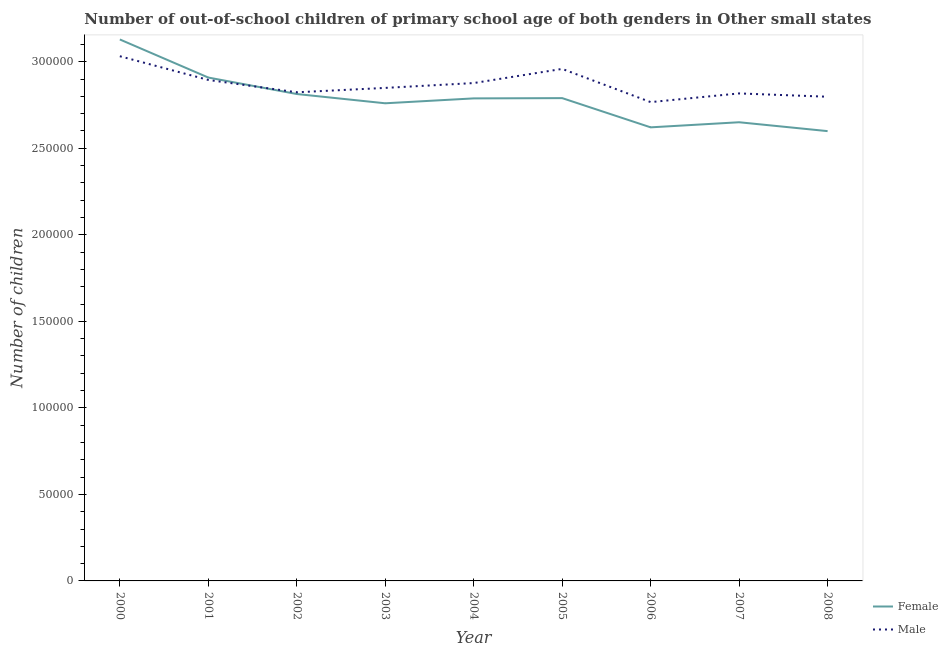Is the number of lines equal to the number of legend labels?
Give a very brief answer. Yes. What is the number of male out-of-school students in 2006?
Your answer should be compact. 2.77e+05. Across all years, what is the maximum number of male out-of-school students?
Keep it short and to the point. 3.03e+05. Across all years, what is the minimum number of male out-of-school students?
Ensure brevity in your answer.  2.77e+05. In which year was the number of female out-of-school students minimum?
Ensure brevity in your answer.  2008. What is the total number of male out-of-school students in the graph?
Offer a terse response. 2.58e+06. What is the difference between the number of male out-of-school students in 2003 and that in 2005?
Ensure brevity in your answer.  -1.10e+04. What is the difference between the number of female out-of-school students in 2004 and the number of male out-of-school students in 2001?
Give a very brief answer. -1.07e+04. What is the average number of female out-of-school students per year?
Offer a terse response. 2.78e+05. In the year 2008, what is the difference between the number of male out-of-school students and number of female out-of-school students?
Your response must be concise. 1.99e+04. What is the ratio of the number of female out-of-school students in 2000 to that in 2006?
Offer a very short reply. 1.19. Is the number of male out-of-school students in 2001 less than that in 2002?
Provide a succinct answer. No. Is the difference between the number of female out-of-school students in 2000 and 2008 greater than the difference between the number of male out-of-school students in 2000 and 2008?
Provide a succinct answer. Yes. What is the difference between the highest and the second highest number of female out-of-school students?
Your answer should be very brief. 2.20e+04. What is the difference between the highest and the lowest number of male out-of-school students?
Ensure brevity in your answer.  2.65e+04. In how many years, is the number of female out-of-school students greater than the average number of female out-of-school students taken over all years?
Keep it short and to the point. 5. Does the number of male out-of-school students monotonically increase over the years?
Provide a short and direct response. No. Is the number of female out-of-school students strictly greater than the number of male out-of-school students over the years?
Provide a succinct answer. No. Is the number of female out-of-school students strictly less than the number of male out-of-school students over the years?
Make the answer very short. No. How many years are there in the graph?
Offer a terse response. 9. Does the graph contain grids?
Offer a very short reply. No. Where does the legend appear in the graph?
Your answer should be very brief. Bottom right. How many legend labels are there?
Your response must be concise. 2. What is the title of the graph?
Your answer should be compact. Number of out-of-school children of primary school age of both genders in Other small states. What is the label or title of the X-axis?
Provide a short and direct response. Year. What is the label or title of the Y-axis?
Offer a terse response. Number of children. What is the Number of children in Female in 2000?
Give a very brief answer. 3.13e+05. What is the Number of children in Male in 2000?
Your answer should be compact. 3.03e+05. What is the Number of children of Female in 2001?
Give a very brief answer. 2.91e+05. What is the Number of children of Male in 2001?
Ensure brevity in your answer.  2.90e+05. What is the Number of children of Female in 2002?
Your answer should be compact. 2.81e+05. What is the Number of children of Male in 2002?
Make the answer very short. 2.82e+05. What is the Number of children in Female in 2003?
Provide a short and direct response. 2.76e+05. What is the Number of children of Male in 2003?
Keep it short and to the point. 2.85e+05. What is the Number of children in Female in 2004?
Give a very brief answer. 2.79e+05. What is the Number of children of Male in 2004?
Offer a terse response. 2.88e+05. What is the Number of children in Female in 2005?
Provide a short and direct response. 2.79e+05. What is the Number of children of Male in 2005?
Your answer should be compact. 2.96e+05. What is the Number of children of Female in 2006?
Your answer should be very brief. 2.62e+05. What is the Number of children in Male in 2006?
Your answer should be compact. 2.77e+05. What is the Number of children in Female in 2007?
Your answer should be compact. 2.65e+05. What is the Number of children in Male in 2007?
Offer a terse response. 2.82e+05. What is the Number of children of Female in 2008?
Provide a short and direct response. 2.60e+05. What is the Number of children of Male in 2008?
Make the answer very short. 2.80e+05. Across all years, what is the maximum Number of children of Female?
Offer a very short reply. 3.13e+05. Across all years, what is the maximum Number of children in Male?
Offer a terse response. 3.03e+05. Across all years, what is the minimum Number of children of Female?
Offer a very short reply. 2.60e+05. Across all years, what is the minimum Number of children of Male?
Provide a short and direct response. 2.77e+05. What is the total Number of children of Female in the graph?
Keep it short and to the point. 2.51e+06. What is the total Number of children in Male in the graph?
Make the answer very short. 2.58e+06. What is the difference between the Number of children of Female in 2000 and that in 2001?
Give a very brief answer. 2.20e+04. What is the difference between the Number of children of Male in 2000 and that in 2001?
Offer a very short reply. 1.37e+04. What is the difference between the Number of children in Female in 2000 and that in 2002?
Your answer should be very brief. 3.15e+04. What is the difference between the Number of children in Male in 2000 and that in 2002?
Offer a very short reply. 2.08e+04. What is the difference between the Number of children in Female in 2000 and that in 2003?
Offer a terse response. 3.69e+04. What is the difference between the Number of children of Male in 2000 and that in 2003?
Offer a terse response. 1.83e+04. What is the difference between the Number of children of Female in 2000 and that in 2004?
Ensure brevity in your answer.  3.41e+04. What is the difference between the Number of children in Male in 2000 and that in 2004?
Make the answer very short. 1.55e+04. What is the difference between the Number of children in Female in 2000 and that in 2005?
Offer a terse response. 3.39e+04. What is the difference between the Number of children in Male in 2000 and that in 2005?
Keep it short and to the point. 7325. What is the difference between the Number of children of Female in 2000 and that in 2006?
Provide a succinct answer. 5.08e+04. What is the difference between the Number of children in Male in 2000 and that in 2006?
Your answer should be very brief. 2.65e+04. What is the difference between the Number of children in Female in 2000 and that in 2007?
Provide a short and direct response. 4.78e+04. What is the difference between the Number of children in Male in 2000 and that in 2007?
Offer a very short reply. 2.15e+04. What is the difference between the Number of children in Female in 2000 and that in 2008?
Your answer should be compact. 5.30e+04. What is the difference between the Number of children of Male in 2000 and that in 2008?
Offer a very short reply. 2.34e+04. What is the difference between the Number of children of Female in 2001 and that in 2002?
Your response must be concise. 9517. What is the difference between the Number of children in Male in 2001 and that in 2002?
Provide a short and direct response. 7131. What is the difference between the Number of children of Female in 2001 and that in 2003?
Make the answer very short. 1.49e+04. What is the difference between the Number of children in Male in 2001 and that in 2003?
Keep it short and to the point. 4598. What is the difference between the Number of children of Female in 2001 and that in 2004?
Ensure brevity in your answer.  1.20e+04. What is the difference between the Number of children of Male in 2001 and that in 2004?
Your answer should be compact. 1800. What is the difference between the Number of children in Female in 2001 and that in 2005?
Provide a succinct answer. 1.19e+04. What is the difference between the Number of children in Male in 2001 and that in 2005?
Keep it short and to the point. -6383. What is the difference between the Number of children in Female in 2001 and that in 2006?
Ensure brevity in your answer.  2.88e+04. What is the difference between the Number of children in Male in 2001 and that in 2006?
Your response must be concise. 1.28e+04. What is the difference between the Number of children of Female in 2001 and that in 2007?
Provide a succinct answer. 2.58e+04. What is the difference between the Number of children in Male in 2001 and that in 2007?
Offer a very short reply. 7787. What is the difference between the Number of children in Female in 2001 and that in 2008?
Your response must be concise. 3.10e+04. What is the difference between the Number of children in Male in 2001 and that in 2008?
Your response must be concise. 9703. What is the difference between the Number of children of Female in 2002 and that in 2003?
Provide a short and direct response. 5357. What is the difference between the Number of children in Male in 2002 and that in 2003?
Your response must be concise. -2533. What is the difference between the Number of children of Female in 2002 and that in 2004?
Give a very brief answer. 2528. What is the difference between the Number of children of Male in 2002 and that in 2004?
Your response must be concise. -5331. What is the difference between the Number of children in Female in 2002 and that in 2005?
Offer a terse response. 2372. What is the difference between the Number of children in Male in 2002 and that in 2005?
Ensure brevity in your answer.  -1.35e+04. What is the difference between the Number of children in Female in 2002 and that in 2006?
Provide a succinct answer. 1.93e+04. What is the difference between the Number of children in Male in 2002 and that in 2006?
Keep it short and to the point. 5676. What is the difference between the Number of children in Female in 2002 and that in 2007?
Provide a short and direct response. 1.63e+04. What is the difference between the Number of children of Male in 2002 and that in 2007?
Your answer should be very brief. 656. What is the difference between the Number of children of Female in 2002 and that in 2008?
Provide a succinct answer. 2.14e+04. What is the difference between the Number of children of Male in 2002 and that in 2008?
Ensure brevity in your answer.  2572. What is the difference between the Number of children in Female in 2003 and that in 2004?
Offer a terse response. -2829. What is the difference between the Number of children in Male in 2003 and that in 2004?
Ensure brevity in your answer.  -2798. What is the difference between the Number of children of Female in 2003 and that in 2005?
Ensure brevity in your answer.  -2985. What is the difference between the Number of children of Male in 2003 and that in 2005?
Provide a succinct answer. -1.10e+04. What is the difference between the Number of children of Female in 2003 and that in 2006?
Give a very brief answer. 1.39e+04. What is the difference between the Number of children in Male in 2003 and that in 2006?
Provide a succinct answer. 8209. What is the difference between the Number of children in Female in 2003 and that in 2007?
Offer a very short reply. 1.10e+04. What is the difference between the Number of children of Male in 2003 and that in 2007?
Offer a terse response. 3189. What is the difference between the Number of children in Female in 2003 and that in 2008?
Provide a short and direct response. 1.61e+04. What is the difference between the Number of children in Male in 2003 and that in 2008?
Provide a short and direct response. 5105. What is the difference between the Number of children in Female in 2004 and that in 2005?
Provide a short and direct response. -156. What is the difference between the Number of children of Male in 2004 and that in 2005?
Ensure brevity in your answer.  -8183. What is the difference between the Number of children of Female in 2004 and that in 2006?
Offer a very short reply. 1.67e+04. What is the difference between the Number of children in Male in 2004 and that in 2006?
Provide a succinct answer. 1.10e+04. What is the difference between the Number of children of Female in 2004 and that in 2007?
Your answer should be very brief. 1.38e+04. What is the difference between the Number of children in Male in 2004 and that in 2007?
Offer a terse response. 5987. What is the difference between the Number of children of Female in 2004 and that in 2008?
Keep it short and to the point. 1.89e+04. What is the difference between the Number of children in Male in 2004 and that in 2008?
Keep it short and to the point. 7903. What is the difference between the Number of children in Female in 2005 and that in 2006?
Offer a terse response. 1.69e+04. What is the difference between the Number of children in Male in 2005 and that in 2006?
Keep it short and to the point. 1.92e+04. What is the difference between the Number of children of Female in 2005 and that in 2007?
Your answer should be very brief. 1.39e+04. What is the difference between the Number of children of Male in 2005 and that in 2007?
Make the answer very short. 1.42e+04. What is the difference between the Number of children of Female in 2005 and that in 2008?
Make the answer very short. 1.91e+04. What is the difference between the Number of children of Male in 2005 and that in 2008?
Provide a succinct answer. 1.61e+04. What is the difference between the Number of children in Female in 2006 and that in 2007?
Your answer should be compact. -2948. What is the difference between the Number of children of Male in 2006 and that in 2007?
Provide a succinct answer. -5020. What is the difference between the Number of children of Female in 2006 and that in 2008?
Provide a succinct answer. 2182. What is the difference between the Number of children in Male in 2006 and that in 2008?
Make the answer very short. -3104. What is the difference between the Number of children in Female in 2007 and that in 2008?
Ensure brevity in your answer.  5130. What is the difference between the Number of children in Male in 2007 and that in 2008?
Keep it short and to the point. 1916. What is the difference between the Number of children in Female in 2000 and the Number of children in Male in 2001?
Your answer should be very brief. 2.34e+04. What is the difference between the Number of children of Female in 2000 and the Number of children of Male in 2002?
Provide a succinct answer. 3.05e+04. What is the difference between the Number of children of Female in 2000 and the Number of children of Male in 2003?
Provide a succinct answer. 2.80e+04. What is the difference between the Number of children in Female in 2000 and the Number of children in Male in 2004?
Keep it short and to the point. 2.52e+04. What is the difference between the Number of children in Female in 2000 and the Number of children in Male in 2005?
Offer a very short reply. 1.70e+04. What is the difference between the Number of children in Female in 2000 and the Number of children in Male in 2006?
Provide a short and direct response. 3.62e+04. What is the difference between the Number of children of Female in 2000 and the Number of children of Male in 2007?
Provide a short and direct response. 3.12e+04. What is the difference between the Number of children in Female in 2000 and the Number of children in Male in 2008?
Make the answer very short. 3.31e+04. What is the difference between the Number of children of Female in 2001 and the Number of children of Male in 2002?
Your response must be concise. 8518. What is the difference between the Number of children of Female in 2001 and the Number of children of Male in 2003?
Offer a very short reply. 5985. What is the difference between the Number of children of Female in 2001 and the Number of children of Male in 2004?
Your answer should be very brief. 3187. What is the difference between the Number of children of Female in 2001 and the Number of children of Male in 2005?
Your response must be concise. -4996. What is the difference between the Number of children of Female in 2001 and the Number of children of Male in 2006?
Offer a very short reply. 1.42e+04. What is the difference between the Number of children in Female in 2001 and the Number of children in Male in 2007?
Provide a short and direct response. 9174. What is the difference between the Number of children in Female in 2001 and the Number of children in Male in 2008?
Offer a terse response. 1.11e+04. What is the difference between the Number of children in Female in 2002 and the Number of children in Male in 2003?
Provide a succinct answer. -3532. What is the difference between the Number of children of Female in 2002 and the Number of children of Male in 2004?
Make the answer very short. -6330. What is the difference between the Number of children of Female in 2002 and the Number of children of Male in 2005?
Keep it short and to the point. -1.45e+04. What is the difference between the Number of children in Female in 2002 and the Number of children in Male in 2006?
Make the answer very short. 4677. What is the difference between the Number of children in Female in 2002 and the Number of children in Male in 2007?
Offer a very short reply. -343. What is the difference between the Number of children in Female in 2002 and the Number of children in Male in 2008?
Offer a very short reply. 1573. What is the difference between the Number of children of Female in 2003 and the Number of children of Male in 2004?
Offer a terse response. -1.17e+04. What is the difference between the Number of children of Female in 2003 and the Number of children of Male in 2005?
Give a very brief answer. -1.99e+04. What is the difference between the Number of children in Female in 2003 and the Number of children in Male in 2006?
Give a very brief answer. -680. What is the difference between the Number of children in Female in 2003 and the Number of children in Male in 2007?
Your response must be concise. -5700. What is the difference between the Number of children of Female in 2003 and the Number of children of Male in 2008?
Offer a terse response. -3784. What is the difference between the Number of children in Female in 2004 and the Number of children in Male in 2005?
Offer a very short reply. -1.70e+04. What is the difference between the Number of children in Female in 2004 and the Number of children in Male in 2006?
Give a very brief answer. 2149. What is the difference between the Number of children of Female in 2004 and the Number of children of Male in 2007?
Your answer should be very brief. -2871. What is the difference between the Number of children in Female in 2004 and the Number of children in Male in 2008?
Your response must be concise. -955. What is the difference between the Number of children of Female in 2005 and the Number of children of Male in 2006?
Offer a terse response. 2305. What is the difference between the Number of children of Female in 2005 and the Number of children of Male in 2007?
Provide a succinct answer. -2715. What is the difference between the Number of children in Female in 2005 and the Number of children in Male in 2008?
Make the answer very short. -799. What is the difference between the Number of children of Female in 2006 and the Number of children of Male in 2007?
Provide a succinct answer. -1.96e+04. What is the difference between the Number of children in Female in 2006 and the Number of children in Male in 2008?
Keep it short and to the point. -1.77e+04. What is the difference between the Number of children in Female in 2007 and the Number of children in Male in 2008?
Ensure brevity in your answer.  -1.47e+04. What is the average Number of children in Female per year?
Your answer should be compact. 2.78e+05. What is the average Number of children of Male per year?
Provide a succinct answer. 2.87e+05. In the year 2000, what is the difference between the Number of children in Female and Number of children in Male?
Provide a succinct answer. 9688. In the year 2001, what is the difference between the Number of children in Female and Number of children in Male?
Make the answer very short. 1387. In the year 2002, what is the difference between the Number of children in Female and Number of children in Male?
Your response must be concise. -999. In the year 2003, what is the difference between the Number of children of Female and Number of children of Male?
Offer a very short reply. -8889. In the year 2004, what is the difference between the Number of children in Female and Number of children in Male?
Offer a very short reply. -8858. In the year 2005, what is the difference between the Number of children in Female and Number of children in Male?
Give a very brief answer. -1.69e+04. In the year 2006, what is the difference between the Number of children of Female and Number of children of Male?
Your answer should be compact. -1.46e+04. In the year 2007, what is the difference between the Number of children in Female and Number of children in Male?
Ensure brevity in your answer.  -1.67e+04. In the year 2008, what is the difference between the Number of children in Female and Number of children in Male?
Offer a very short reply. -1.99e+04. What is the ratio of the Number of children of Female in 2000 to that in 2001?
Make the answer very short. 1.08. What is the ratio of the Number of children of Male in 2000 to that in 2001?
Offer a very short reply. 1.05. What is the ratio of the Number of children of Female in 2000 to that in 2002?
Your response must be concise. 1.11. What is the ratio of the Number of children in Male in 2000 to that in 2002?
Your response must be concise. 1.07. What is the ratio of the Number of children in Female in 2000 to that in 2003?
Provide a short and direct response. 1.13. What is the ratio of the Number of children of Male in 2000 to that in 2003?
Give a very brief answer. 1.06. What is the ratio of the Number of children of Female in 2000 to that in 2004?
Offer a terse response. 1.12. What is the ratio of the Number of children in Male in 2000 to that in 2004?
Provide a succinct answer. 1.05. What is the ratio of the Number of children in Female in 2000 to that in 2005?
Provide a succinct answer. 1.12. What is the ratio of the Number of children in Male in 2000 to that in 2005?
Provide a short and direct response. 1.02. What is the ratio of the Number of children in Female in 2000 to that in 2006?
Your response must be concise. 1.19. What is the ratio of the Number of children of Male in 2000 to that in 2006?
Make the answer very short. 1.1. What is the ratio of the Number of children in Female in 2000 to that in 2007?
Your response must be concise. 1.18. What is the ratio of the Number of children in Male in 2000 to that in 2007?
Keep it short and to the point. 1.08. What is the ratio of the Number of children in Female in 2000 to that in 2008?
Your answer should be compact. 1.2. What is the ratio of the Number of children in Male in 2000 to that in 2008?
Keep it short and to the point. 1.08. What is the ratio of the Number of children of Female in 2001 to that in 2002?
Make the answer very short. 1.03. What is the ratio of the Number of children of Male in 2001 to that in 2002?
Make the answer very short. 1.03. What is the ratio of the Number of children of Female in 2001 to that in 2003?
Ensure brevity in your answer.  1.05. What is the ratio of the Number of children of Male in 2001 to that in 2003?
Keep it short and to the point. 1.02. What is the ratio of the Number of children in Female in 2001 to that in 2004?
Make the answer very short. 1.04. What is the ratio of the Number of children in Male in 2001 to that in 2004?
Keep it short and to the point. 1.01. What is the ratio of the Number of children of Female in 2001 to that in 2005?
Provide a succinct answer. 1.04. What is the ratio of the Number of children of Male in 2001 to that in 2005?
Offer a terse response. 0.98. What is the ratio of the Number of children in Female in 2001 to that in 2006?
Ensure brevity in your answer.  1.11. What is the ratio of the Number of children of Male in 2001 to that in 2006?
Your answer should be compact. 1.05. What is the ratio of the Number of children in Female in 2001 to that in 2007?
Provide a succinct answer. 1.1. What is the ratio of the Number of children of Male in 2001 to that in 2007?
Give a very brief answer. 1.03. What is the ratio of the Number of children in Female in 2001 to that in 2008?
Give a very brief answer. 1.12. What is the ratio of the Number of children of Male in 2001 to that in 2008?
Make the answer very short. 1.03. What is the ratio of the Number of children of Female in 2002 to that in 2003?
Give a very brief answer. 1.02. What is the ratio of the Number of children of Female in 2002 to that in 2004?
Your answer should be compact. 1.01. What is the ratio of the Number of children of Male in 2002 to that in 2004?
Offer a very short reply. 0.98. What is the ratio of the Number of children in Female in 2002 to that in 2005?
Make the answer very short. 1.01. What is the ratio of the Number of children of Male in 2002 to that in 2005?
Your response must be concise. 0.95. What is the ratio of the Number of children in Female in 2002 to that in 2006?
Your answer should be very brief. 1.07. What is the ratio of the Number of children in Male in 2002 to that in 2006?
Ensure brevity in your answer.  1.02. What is the ratio of the Number of children of Female in 2002 to that in 2007?
Your answer should be very brief. 1.06. What is the ratio of the Number of children in Female in 2002 to that in 2008?
Make the answer very short. 1.08. What is the ratio of the Number of children of Male in 2002 to that in 2008?
Your answer should be compact. 1.01. What is the ratio of the Number of children of Male in 2003 to that in 2004?
Give a very brief answer. 0.99. What is the ratio of the Number of children of Female in 2003 to that in 2005?
Keep it short and to the point. 0.99. What is the ratio of the Number of children in Male in 2003 to that in 2005?
Offer a very short reply. 0.96. What is the ratio of the Number of children in Female in 2003 to that in 2006?
Your answer should be very brief. 1.05. What is the ratio of the Number of children of Male in 2003 to that in 2006?
Provide a succinct answer. 1.03. What is the ratio of the Number of children in Female in 2003 to that in 2007?
Give a very brief answer. 1.04. What is the ratio of the Number of children in Male in 2003 to that in 2007?
Your answer should be very brief. 1.01. What is the ratio of the Number of children of Female in 2003 to that in 2008?
Provide a short and direct response. 1.06. What is the ratio of the Number of children of Male in 2003 to that in 2008?
Your answer should be very brief. 1.02. What is the ratio of the Number of children of Male in 2004 to that in 2005?
Provide a succinct answer. 0.97. What is the ratio of the Number of children in Female in 2004 to that in 2006?
Ensure brevity in your answer.  1.06. What is the ratio of the Number of children in Male in 2004 to that in 2006?
Your answer should be very brief. 1.04. What is the ratio of the Number of children of Female in 2004 to that in 2007?
Your response must be concise. 1.05. What is the ratio of the Number of children in Male in 2004 to that in 2007?
Your answer should be very brief. 1.02. What is the ratio of the Number of children in Female in 2004 to that in 2008?
Offer a terse response. 1.07. What is the ratio of the Number of children of Male in 2004 to that in 2008?
Make the answer very short. 1.03. What is the ratio of the Number of children of Female in 2005 to that in 2006?
Your answer should be compact. 1.06. What is the ratio of the Number of children in Male in 2005 to that in 2006?
Provide a short and direct response. 1.07. What is the ratio of the Number of children of Female in 2005 to that in 2007?
Provide a short and direct response. 1.05. What is the ratio of the Number of children of Male in 2005 to that in 2007?
Provide a succinct answer. 1.05. What is the ratio of the Number of children in Female in 2005 to that in 2008?
Provide a succinct answer. 1.07. What is the ratio of the Number of children of Male in 2005 to that in 2008?
Make the answer very short. 1.06. What is the ratio of the Number of children in Female in 2006 to that in 2007?
Offer a very short reply. 0.99. What is the ratio of the Number of children of Male in 2006 to that in 2007?
Provide a succinct answer. 0.98. What is the ratio of the Number of children in Female in 2006 to that in 2008?
Keep it short and to the point. 1.01. What is the ratio of the Number of children of Male in 2006 to that in 2008?
Give a very brief answer. 0.99. What is the ratio of the Number of children in Female in 2007 to that in 2008?
Your answer should be compact. 1.02. What is the ratio of the Number of children in Male in 2007 to that in 2008?
Offer a very short reply. 1.01. What is the difference between the highest and the second highest Number of children of Female?
Make the answer very short. 2.20e+04. What is the difference between the highest and the second highest Number of children in Male?
Offer a very short reply. 7325. What is the difference between the highest and the lowest Number of children in Female?
Your answer should be very brief. 5.30e+04. What is the difference between the highest and the lowest Number of children in Male?
Offer a very short reply. 2.65e+04. 